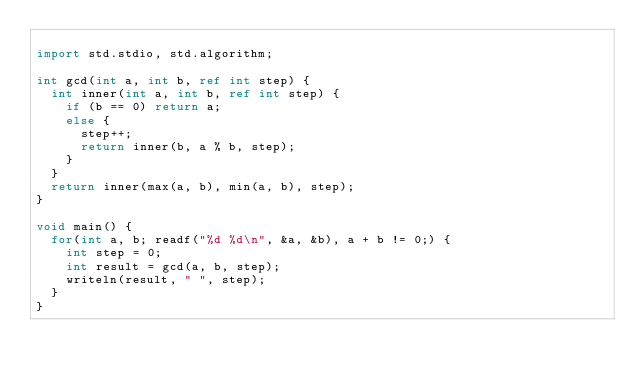<code> <loc_0><loc_0><loc_500><loc_500><_D_>
import std.stdio, std.algorithm;

int gcd(int a, int b, ref int step) {
  int inner(int a, int b, ref int step) {
    if (b == 0) return a;
    else {
      step++;
      return inner(b, a % b, step);
    }    
  }
  return inner(max(a, b), min(a, b), step);
}

void main() {
  for(int a, b; readf("%d %d\n", &a, &b), a + b != 0;) {
    int step = 0;
    int result = gcd(a, b, step);
    writeln(result, " ", step);
  }
}</code> 